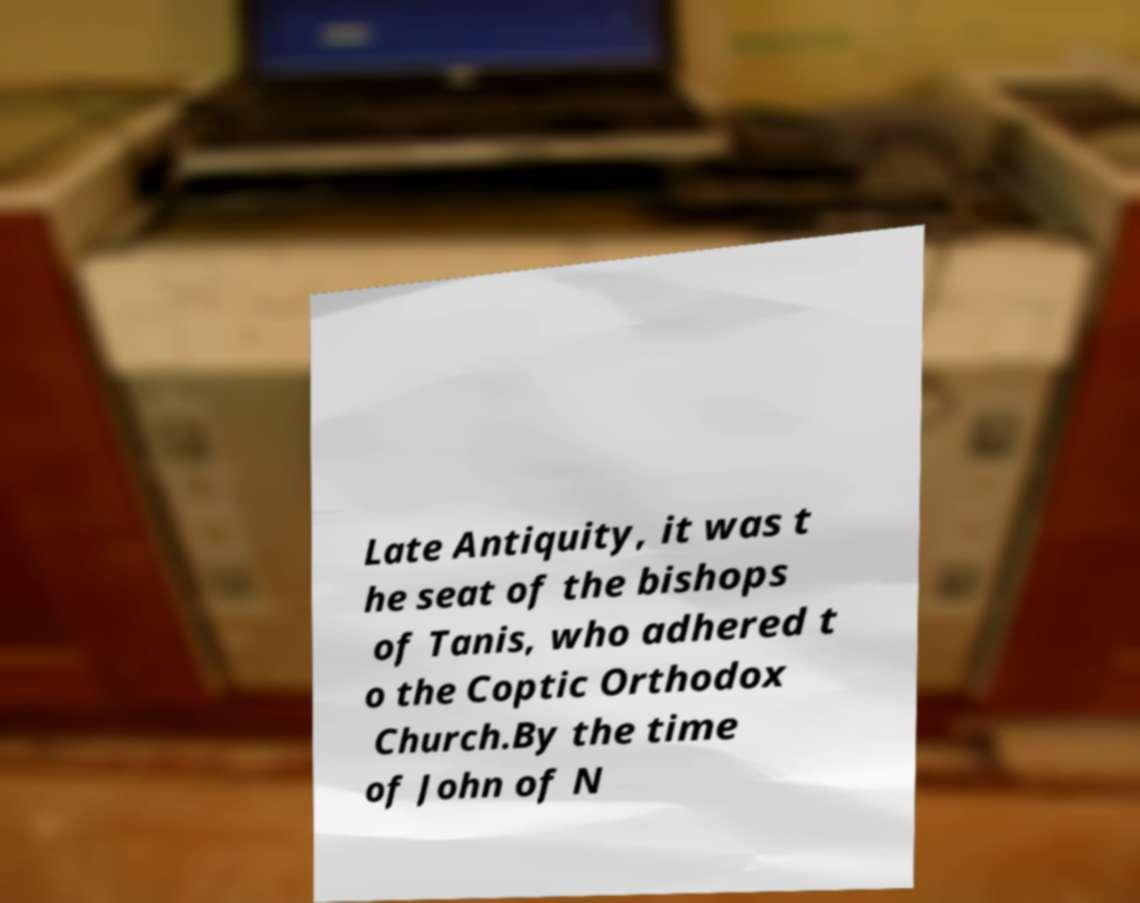I need the written content from this picture converted into text. Can you do that? Late Antiquity, it was t he seat of the bishops of Tanis, who adhered t o the Coptic Orthodox Church.By the time of John of N 